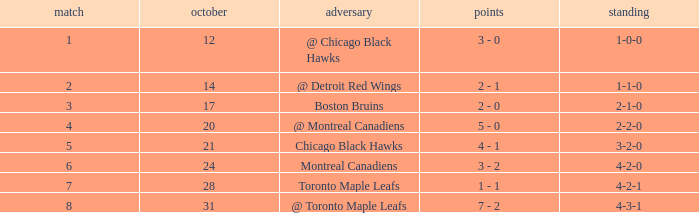What was the record for the game before game 6 against the chicago black hawks? 3-2-0. 